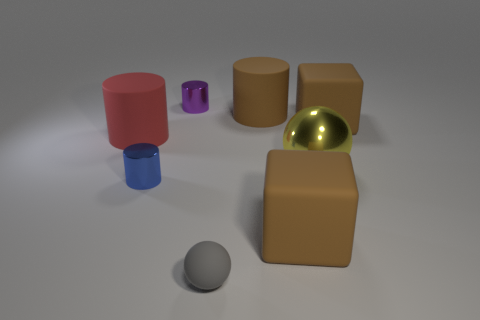Are there fewer metallic things in front of the red thing than big brown rubber objects behind the tiny gray object?
Your answer should be very brief. Yes. How many other things are there of the same shape as the purple metal object?
Offer a terse response. 3. The tiny object that is made of the same material as the brown cylinder is what shape?
Your answer should be compact. Sphere. What is the color of the metal object that is behind the blue shiny object and in front of the brown cylinder?
Provide a succinct answer. Yellow. Is the material of the tiny cylinder in front of the small purple metallic cylinder the same as the red cylinder?
Ensure brevity in your answer.  No. Are there fewer small purple things that are left of the purple metal thing than tiny green cylinders?
Make the answer very short. No. Are there any tiny gray cylinders that have the same material as the purple cylinder?
Offer a very short reply. No. There is a yellow metallic ball; is its size the same as the matte cylinder that is left of the small purple cylinder?
Offer a very short reply. Yes. Are there any big metallic objects that have the same color as the metal sphere?
Your response must be concise. No. Are the big red cylinder and the tiny blue cylinder made of the same material?
Make the answer very short. No. 